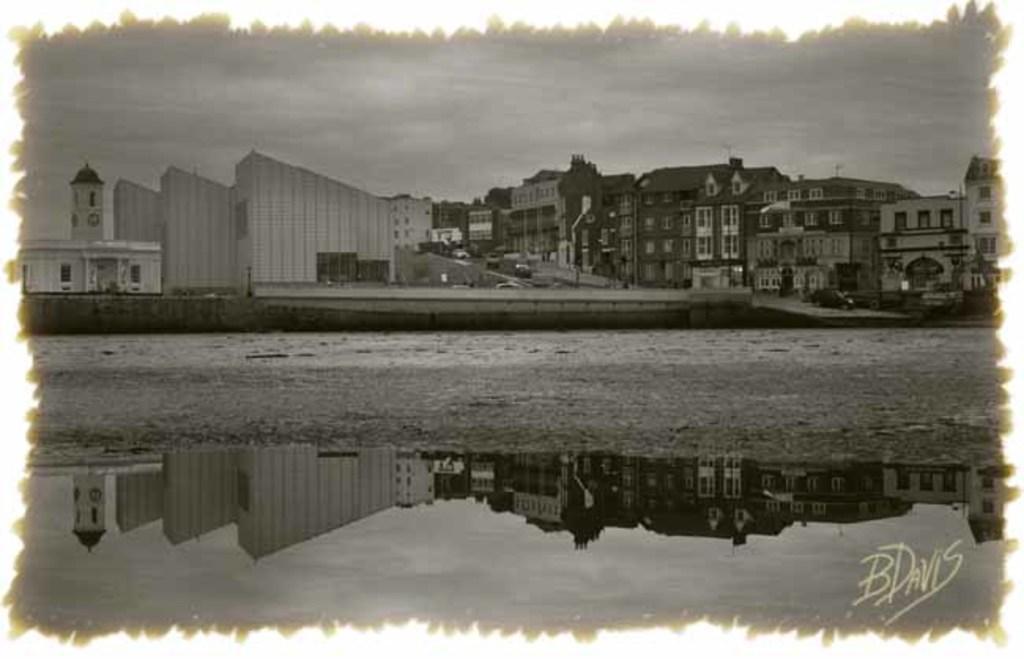Describe this image in one or two sentences. This image is in black and white where we can see the road, buildings and the sky. Here we can see the reflection of the above image in the water. Here we can see the watermark. 